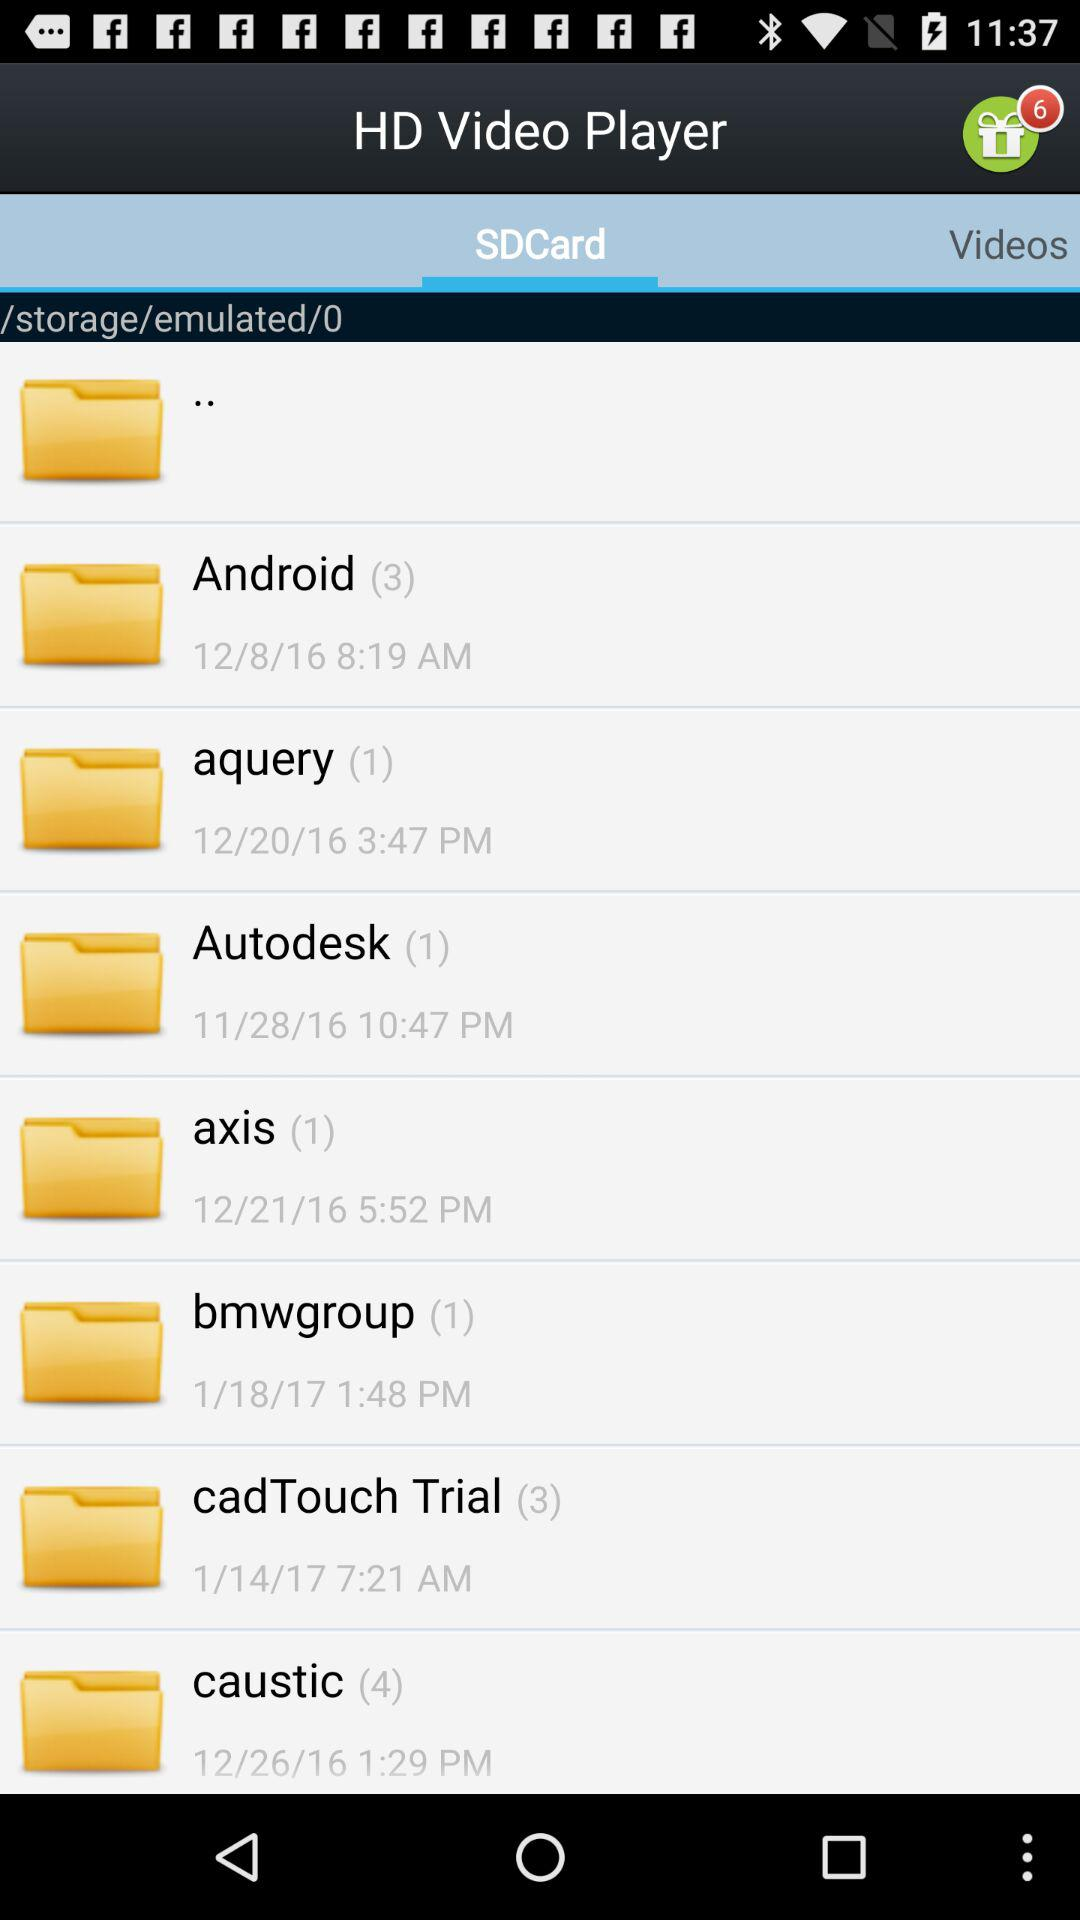What is the number of new gifts? The number of new gifts is 6. 